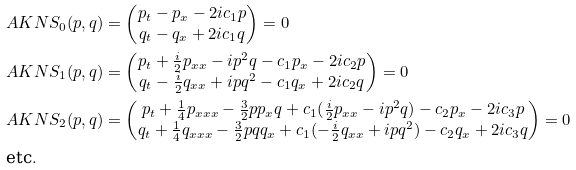Convert formula to latex. <formula><loc_0><loc_0><loc_500><loc_500>& A K N S _ { 0 } ( p , q ) = \begin{pmatrix} p _ { t } - p _ { x } - 2 i c _ { 1 } p \\ q _ { t } - q _ { x } + 2 i c _ { 1 } q \end{pmatrix} = 0 \\ & A K N S _ { 1 } ( p , q ) = \begin{pmatrix} p _ { t } + \frac { i } { 2 } p _ { x x } - i p ^ { 2 } q - c _ { 1 } p _ { x } - 2 i c _ { 2 } p \\ q _ { t } - \frac { i } { 2 } q _ { x x } + i p q ^ { 2 } - c _ { 1 } q _ { x } + 2 i c _ { 2 } q \end{pmatrix} = 0 \\ & A K N S _ { 2 } ( p , q ) = \begin{pmatrix} p _ { t } + \frac { 1 } { 4 } p _ { x x x } - \frac { 3 } { 2 } p p _ { x } q + c _ { 1 } ( \frac { i } 2 p _ { x x } - i p ^ { 2 } q ) - c _ { 2 } p _ { x } - 2 i c _ { 3 } p \\ q _ { t } + \frac { 1 } { 4 } q _ { x x x } - \frac { 3 } { 2 } p q q _ { x } + c _ { 1 } ( - \frac { i } 2 q _ { x x } + i p q ^ { 2 } ) - c _ { 2 } q _ { x } + 2 i c _ { 3 } q \end{pmatrix} = 0 \\ & \text {etc} .</formula> 